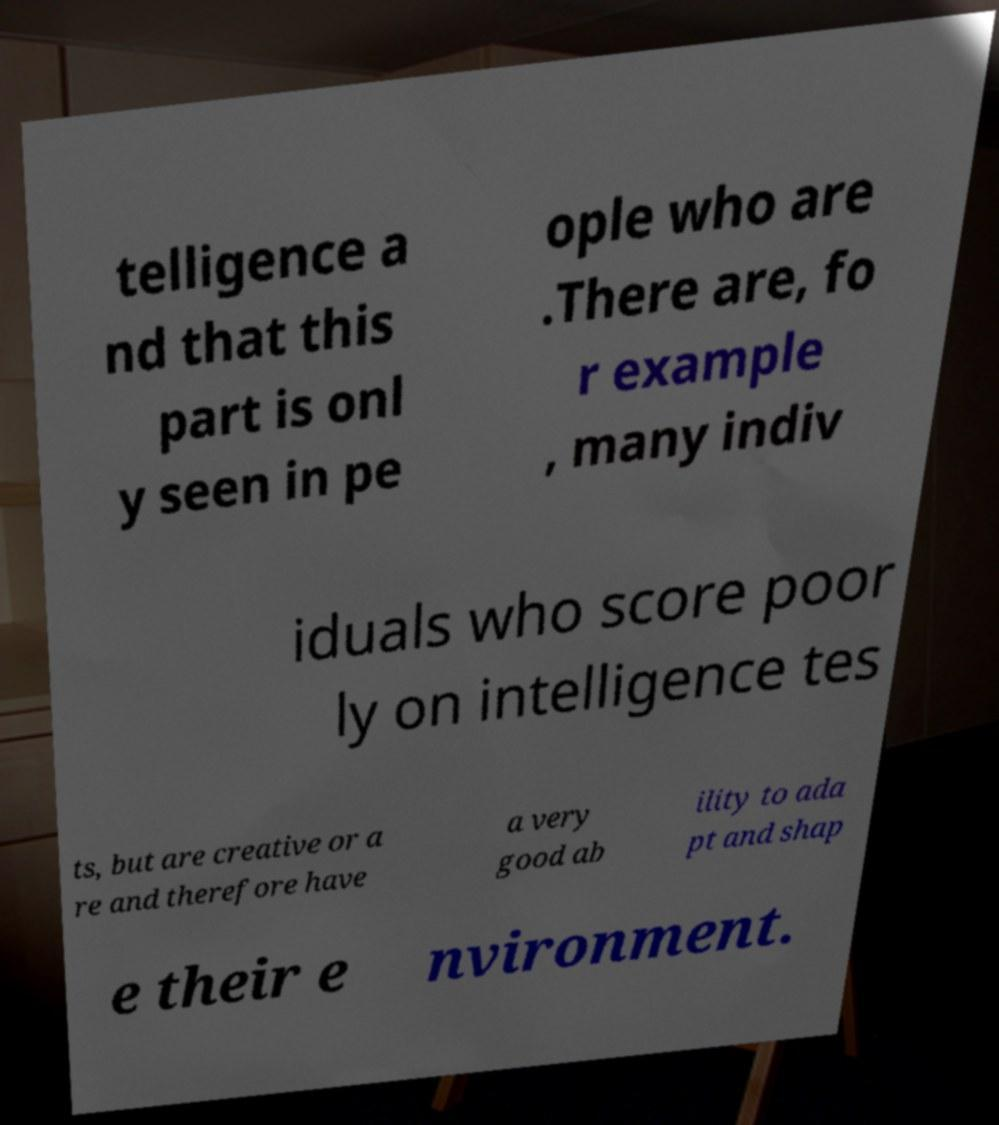For documentation purposes, I need the text within this image transcribed. Could you provide that? telligence a nd that this part is onl y seen in pe ople who are .There are, fo r example , many indiv iduals who score poor ly on intelligence tes ts, but are creative or a re and therefore have a very good ab ility to ada pt and shap e their e nvironment. 